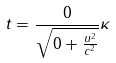<formula> <loc_0><loc_0><loc_500><loc_500>t = \frac { 0 } { \sqrt { 0 + \frac { u ^ { 2 } } { c ^ { 2 } } } } \kappa</formula> 